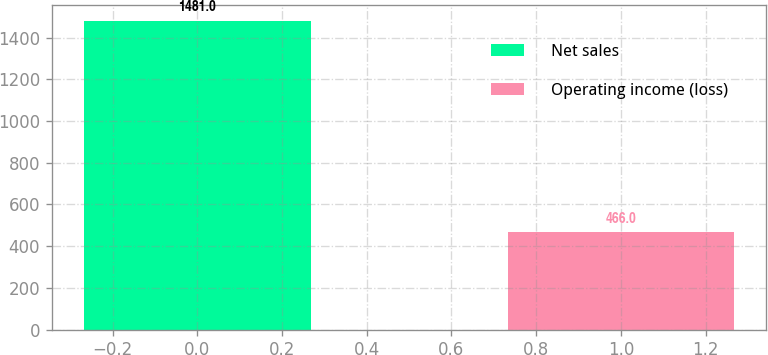Convert chart to OTSL. <chart><loc_0><loc_0><loc_500><loc_500><bar_chart><fcel>Net sales<fcel>Operating income (loss)<nl><fcel>1481<fcel>466<nl></chart> 